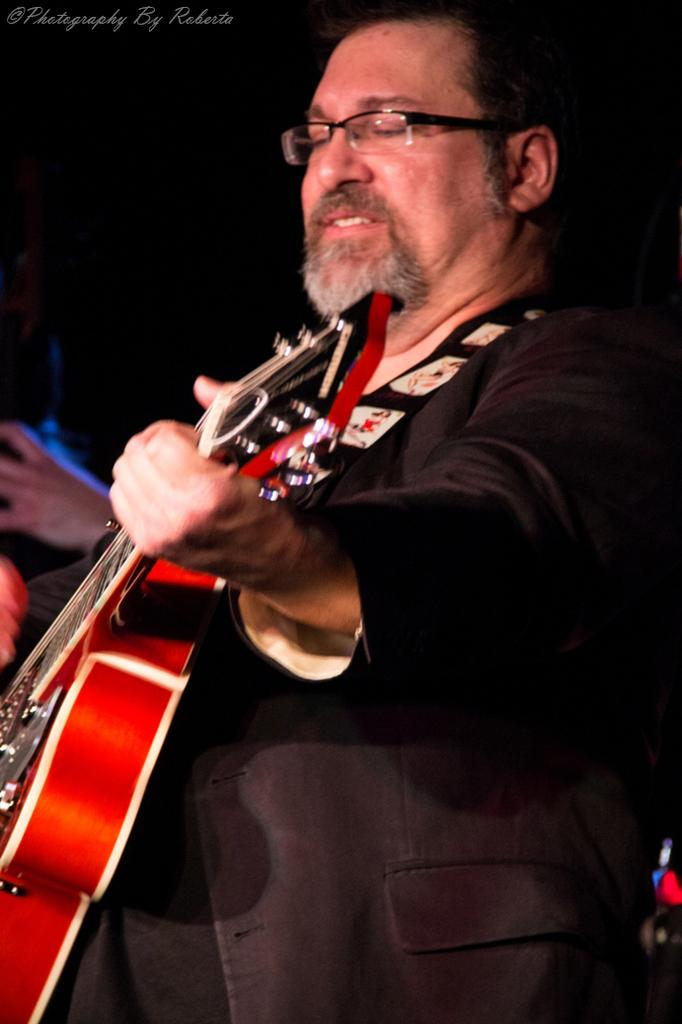What is the man in the image doing? The man is playing a guitar. What is the man wearing in the image? The man is wearing a black suit. How many cattle are visible in the image? There are no cattle present in the image. What type of plate is the man using to play the guitar? The man is not using a plate to play the guitar; he is using his hands and fingers. 